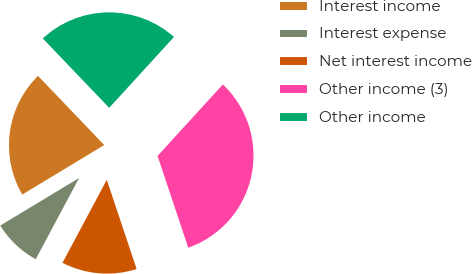<chart> <loc_0><loc_0><loc_500><loc_500><pie_chart><fcel>Interest income<fcel>Interest expense<fcel>Net interest income<fcel>Other income (3)<fcel>Other income<nl><fcel>21.49%<fcel>8.55%<fcel>12.94%<fcel>33.08%<fcel>23.94%<nl></chart> 